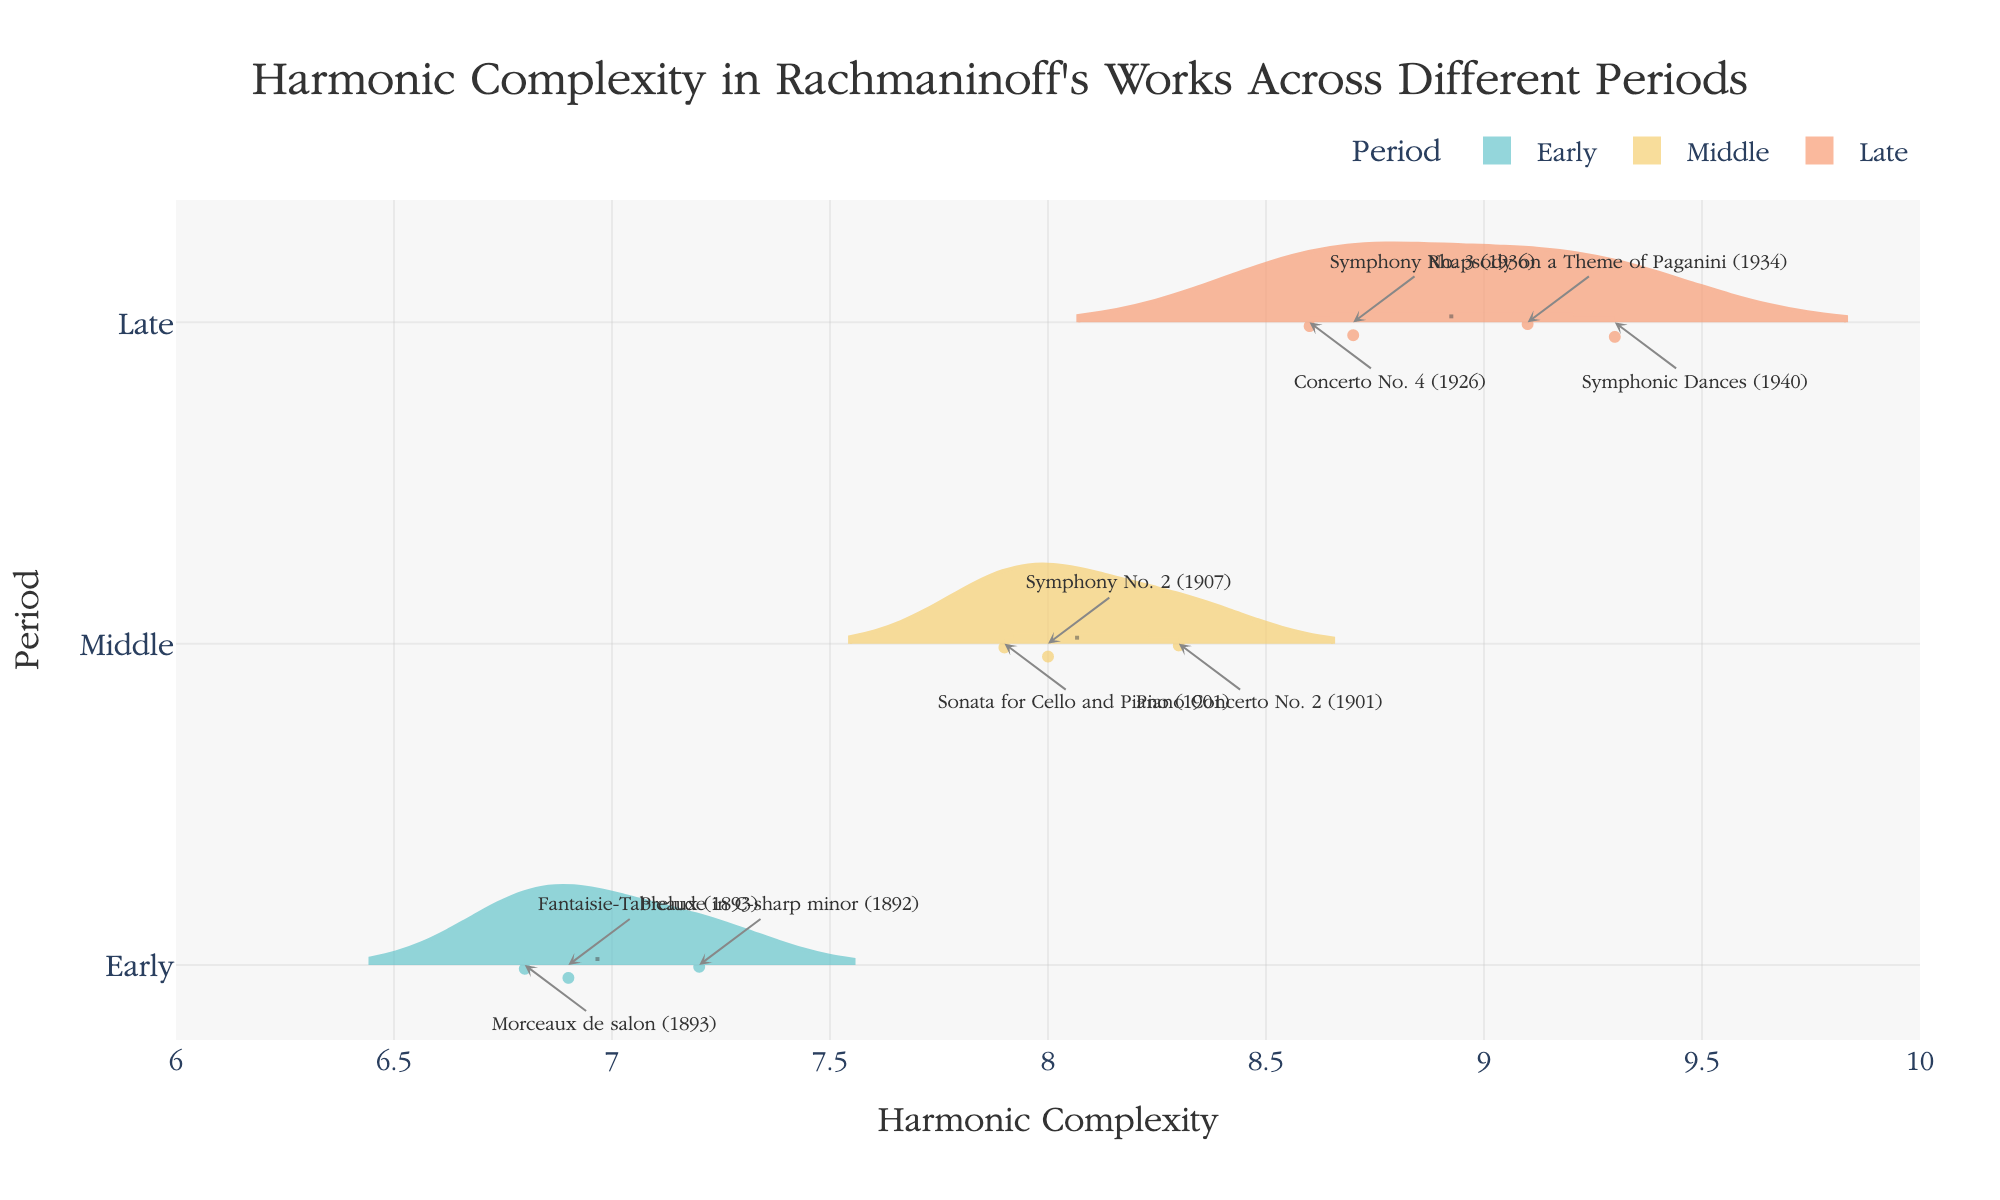What is the title of the chart? The title of the chart is displayed at the top center of the figure. It typically provides the main subject and context of the visualization.
Answer: Harmonic Complexity in Rachmaninoff's Works Across Different Periods How many pieces are analyzed from the Middle period? To determine the number of analyzed pieces from the Middle period, count the data points or annotations within the Middle period section.
Answer: 3 What is the mean harmonic complexity during the Late period? The mean harmonic complexity is depicted by the mean line within the violin plot. For the Late period, locate the mean line in the corresponding violin plot segment and directly observe its position on the x-axis.
Answer: Approximately 8.925 Which piece from the Early period has the lowest harmonic complexity? Look at the annotations or hover points in the Early period section of the violin chart to identify the piece with the lowest x-axis value.
Answer: Morceaux de salon How does the harmonic complexity of "Prelude in C-sharp minor" compare to "Symphonic Dances"? Locate the annotation for "Prelude in C-sharp minor" in the Early period and "Symphonic Dances" in the Late period on the chart and compare their positions along the x-axis.
Answer: Symphonic Dances has higher complexity Which period showcases the highest variation in harmonic complexity? Determine this by observing the spread or distribution of the violin plots. The period with the widest distribution indicates higher variation.
Answer: Late Is there any overlap in harmonic complexity between the Middle and Late periods? Compare the violin plots of the Middle and Late periods to see if they share any common x-axis ranges.
Answer: Yes Which period includes pieces with harmonic complexities exceeding 9.0? Examine the right-most side of the violin plots to see which periods contain data points or annotations above the 9.0 mark on the x-axis.
Answer: Late What is the median harmonic complexity for the Early period? The median value is represented by the central line in the box plot inside the violin plot for the Early period. Locate this line within the Early period section.
Answer: Approximately 6.9 How does the complexity of "Rhapsody on a Theme of Paganini" relate to the average complexity of the Late period? Locate the annotation for "Rhapsody on a Theme of Paganini" and compare its x-axis position to the mean line of the Late period’s violin plot.
Answer: Slightly above the average 